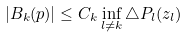<formula> <loc_0><loc_0><loc_500><loc_500>| B _ { k } ( p ) | \leq C _ { k } \inf _ { l \neq k } \triangle P _ { l } ( z _ { l } )</formula> 